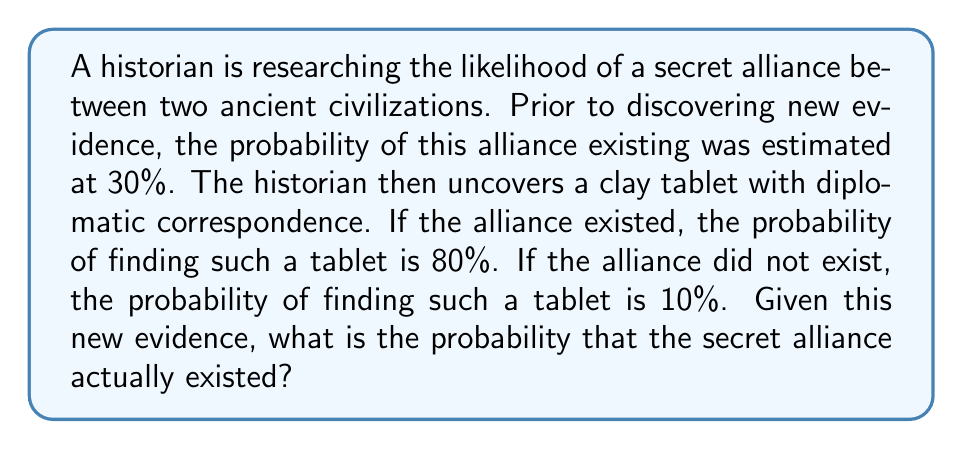Give your solution to this math problem. To solve this problem, we'll use Bayes' Theorem. Let's define our events:

A: The secret alliance existed
B: Finding the clay tablet with diplomatic correspondence

We're given:
$P(A) = 0.30$ (prior probability)
$P(B|A) = 0.80$ (probability of finding the tablet if the alliance existed)
$P(B|\text{not }A) = 0.10$ (probability of finding the tablet if the alliance did not exist)

Bayes' Theorem states:

$$P(A|B) = \frac{P(B|A) \cdot P(A)}{P(B)}$$

To find $P(B)$, we use the law of total probability:

$$P(B) = P(B|A) \cdot P(A) + P(B|\text{not }A) \cdot P(\text{not }A)$$

Step 1: Calculate $P(\text{not }A)$
$P(\text{not }A) = 1 - P(A) = 1 - 0.30 = 0.70$

Step 2: Calculate $P(B)$
$P(B) = (0.80 \cdot 0.30) + (0.10 \cdot 0.70) = 0.24 + 0.07 = 0.31$

Step 3: Apply Bayes' Theorem
$$P(A|B) = \frac{0.80 \cdot 0.30}{0.31} = \frac{0.24}{0.31} \approx 0.7742$$

Therefore, the probability that the secret alliance existed, given the discovery of the clay tablet, is approximately 0.7742 or 77.42%.
Answer: $P(A|B) \approx 0.7742$ or 77.42% 